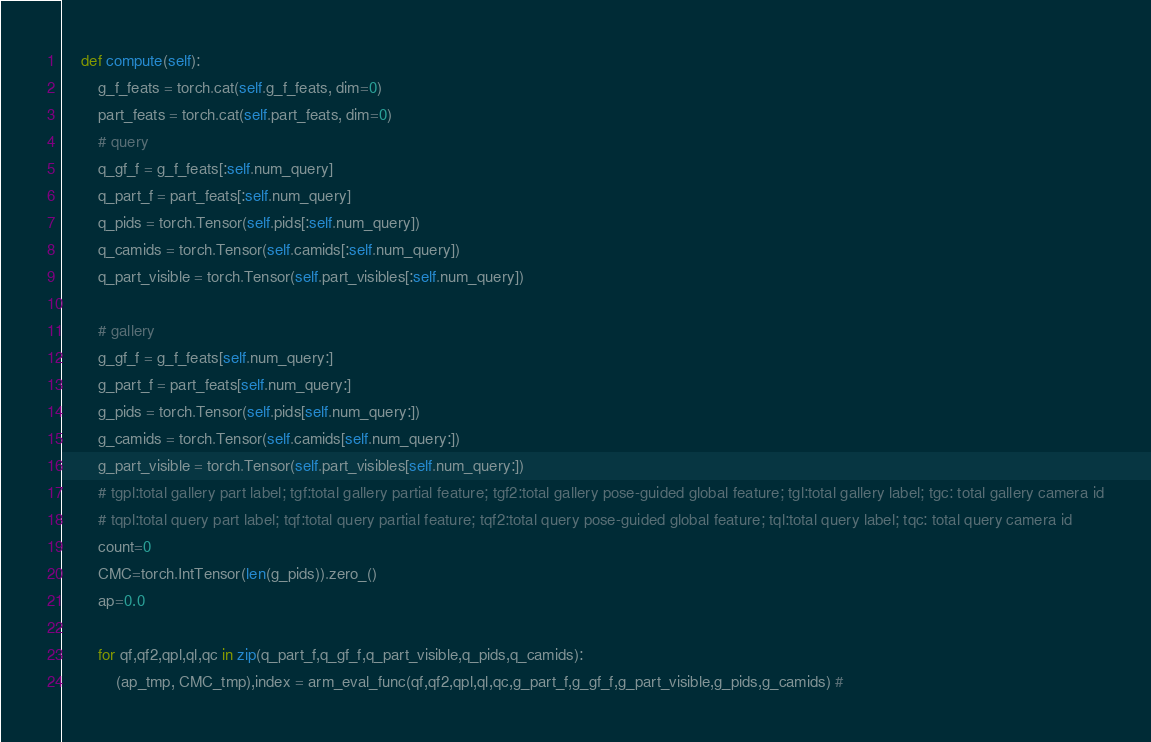<code> <loc_0><loc_0><loc_500><loc_500><_Python_>    def compute(self):
        g_f_feats = torch.cat(self.g_f_feats, dim=0)
        part_feats = torch.cat(self.part_feats, dim=0)
        # query
        q_gf_f = g_f_feats[:self.num_query]
        q_part_f = part_feats[:self.num_query]
        q_pids = torch.Tensor(self.pids[:self.num_query])
        q_camids = torch.Tensor(self.camids[:self.num_query])
        q_part_visible = torch.Tensor(self.part_visibles[:self.num_query])
        
        # gallery
        g_gf_f = g_f_feats[self.num_query:]
        g_part_f = part_feats[self.num_query:]
        g_pids = torch.Tensor(self.pids[self.num_query:])
        g_camids = torch.Tensor(self.camids[self.num_query:])
        g_part_visible = torch.Tensor(self.part_visibles[self.num_query:])
        # tgpl:total gallery part label; tgf:total gallery partial feature; tgf2:total gallery pose-guided global feature; tgl:total gallery label; tgc: total gallery camera id
        # tqpl:total query part label; tqf:total query partial feature; tqf2:total query pose-guided global feature; tql:total query label; tqc: total query camera id
        count=0
        CMC=torch.IntTensor(len(g_pids)).zero_()    
        ap=0.0
      
        for qf,qf2,qpl,ql,qc in zip(q_part_f,q_gf_f,q_part_visible,q_pids,q_camids):
            (ap_tmp, CMC_tmp),index = arm_eval_func(qf,qf2,qpl,ql,qc,g_part_f,g_gf_f,g_part_visible,g_pids,g_camids) #</code> 